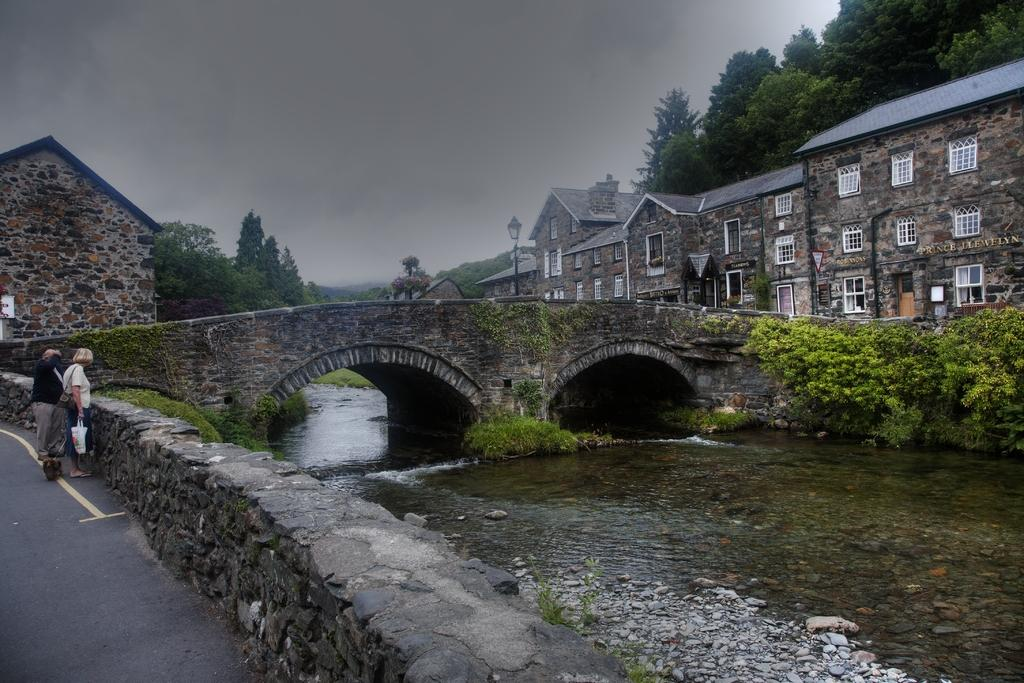What is happening on the right side of the image? Water is flowing on the right side of the image. What structure can be seen in the middle of the image? There is a bridge in the middle of the image. What are the people on the left side of the image doing? The people standing on the left side of the image are observing the scene. What type of buildings are present on the right side of the image? Houses are present on the right side of the image. What other natural elements can be seen on the right side of the image? Trees are visible on the right side of the image. What type of cork is being used to put out the fire in the image? There is no fire or cork present in the image; it features a flowing water body, a bridge, people observing the scene, houses, and trees. 